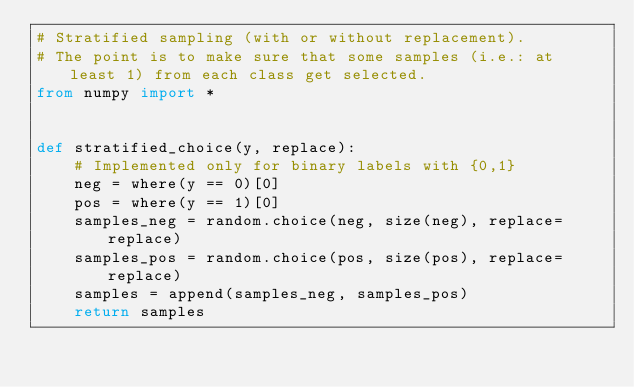<code> <loc_0><loc_0><loc_500><loc_500><_Python_># Stratified sampling (with or without replacement).
# The point is to make sure that some samples (i.e.: at least 1) from each class get selected.
from numpy import *


def stratified_choice(y, replace):
    # Implemented only for binary labels with {0,1}
    neg = where(y == 0)[0]
    pos = where(y == 1)[0]
    samples_neg = random.choice(neg, size(neg), replace=replace)
    samples_pos = random.choice(pos, size(pos), replace=replace)
    samples = append(samples_neg, samples_pos)
    return samples
</code> 